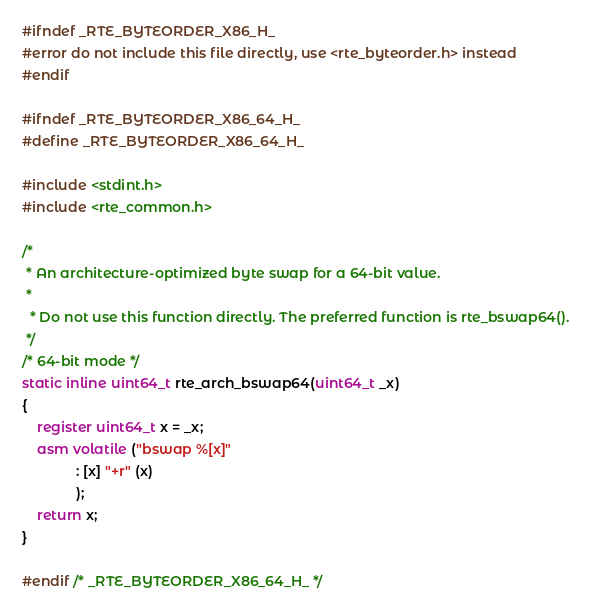<code> <loc_0><loc_0><loc_500><loc_500><_C_>
#ifndef _RTE_BYTEORDER_X86_H_
#error do not include this file directly, use <rte_byteorder.h> instead
#endif

#ifndef _RTE_BYTEORDER_X86_64_H_
#define _RTE_BYTEORDER_X86_64_H_

#include <stdint.h>
#include <rte_common.h>

/*
 * An architecture-optimized byte swap for a 64-bit value.
 *
  * Do not use this function directly. The preferred function is rte_bswap64().
 */
/* 64-bit mode */
static inline uint64_t rte_arch_bswap64(uint64_t _x)
{
	register uint64_t x = _x;
	asm volatile ("bswap %[x]"
		      : [x] "+r" (x)
		      );
	return x;
}

#endif /* _RTE_BYTEORDER_X86_64_H_ */
</code> 